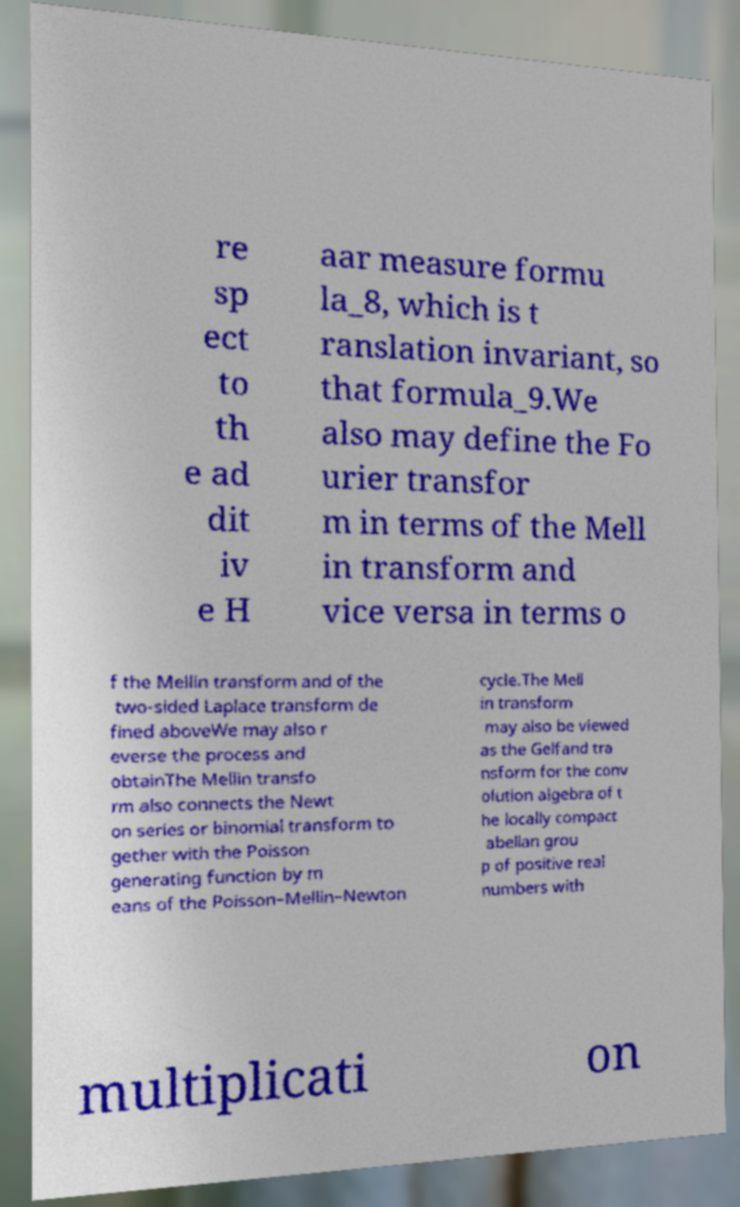Can you read and provide the text displayed in the image?This photo seems to have some interesting text. Can you extract and type it out for me? re sp ect to th e ad dit iv e H aar measure formu la_8, which is t ranslation invariant, so that formula_9.We also may define the Fo urier transfor m in terms of the Mell in transform and vice versa in terms o f the Mellin transform and of the two-sided Laplace transform de fined aboveWe may also r everse the process and obtainThe Mellin transfo rm also connects the Newt on series or binomial transform to gether with the Poisson generating function by m eans of the Poisson–Mellin–Newton cycle.The Mell in transform may also be viewed as the Gelfand tra nsform for the conv olution algebra of t he locally compact abelian grou p of positive real numbers with multiplicati on 